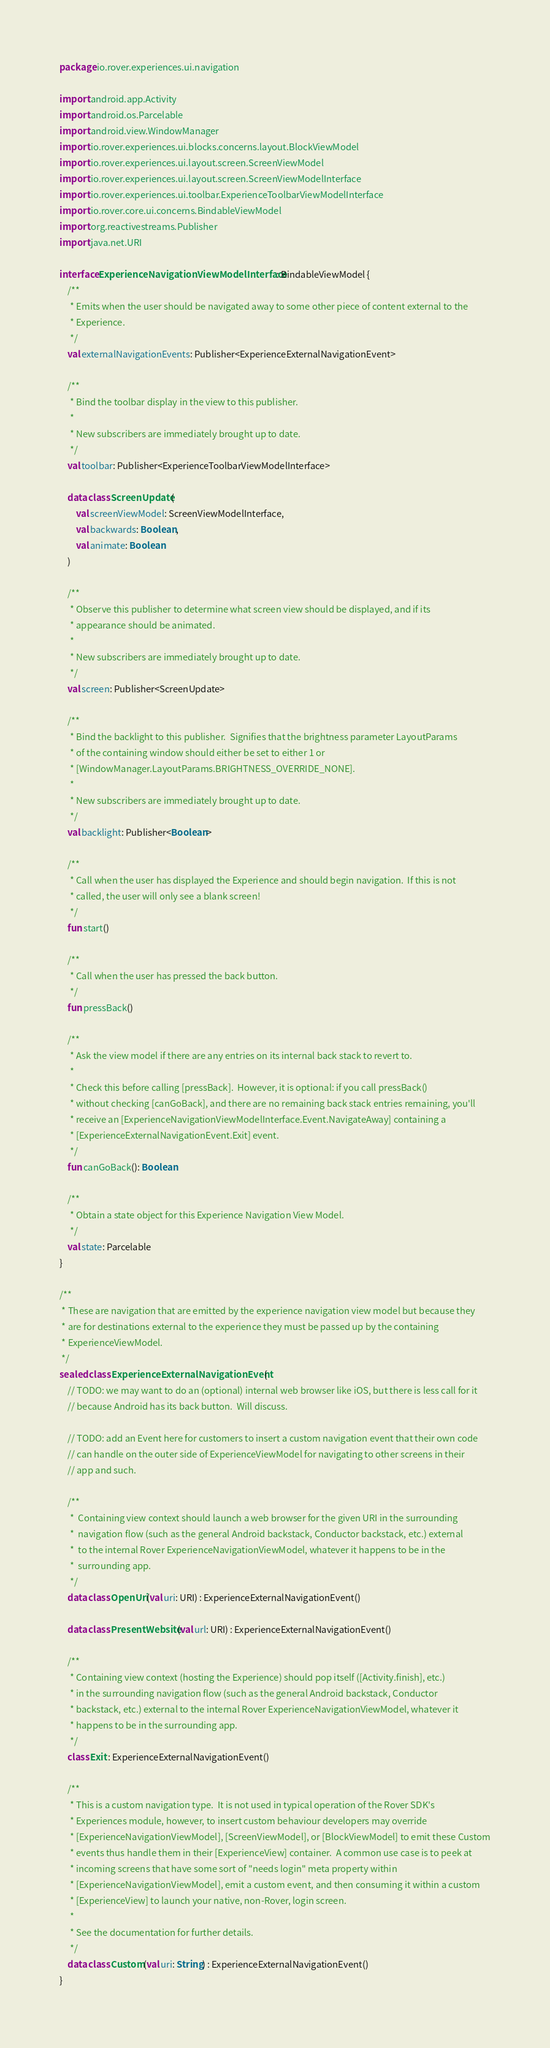Convert code to text. <code><loc_0><loc_0><loc_500><loc_500><_Kotlin_>package io.rover.experiences.ui.navigation

import android.app.Activity
import android.os.Parcelable
import android.view.WindowManager
import io.rover.experiences.ui.blocks.concerns.layout.BlockViewModel
import io.rover.experiences.ui.layout.screen.ScreenViewModel
import io.rover.experiences.ui.layout.screen.ScreenViewModelInterface
import io.rover.experiences.ui.toolbar.ExperienceToolbarViewModelInterface
import io.rover.core.ui.concerns.BindableViewModel
import org.reactivestreams.Publisher
import java.net.URI

interface ExperienceNavigationViewModelInterface : BindableViewModel {
    /**
     * Emits when the user should be navigated away to some other piece of content external to the
     * Experience.
     */
    val externalNavigationEvents: Publisher<ExperienceExternalNavigationEvent>

    /**
     * Bind the toolbar display in the view to this publisher.
     *
     * New subscribers are immediately brought up to date.
     */
    val toolbar: Publisher<ExperienceToolbarViewModelInterface>

    data class ScreenUpdate(
        val screenViewModel: ScreenViewModelInterface,
        val backwards: Boolean,
        val animate: Boolean
    )

    /**
     * Observe this publisher to determine what screen view should be displayed, and if its
     * appearance should be animated.
     *
     * New subscribers are immediately brought up to date.
     */
    val screen: Publisher<ScreenUpdate>

    /**
     * Bind the backlight to this publisher.  Signifies that the brightness parameter LayoutParams
     * of the containing window should either be set to either 1 or
     * [WindowManager.LayoutParams.BRIGHTNESS_OVERRIDE_NONE].
     *
     * New subscribers are immediately brought up to date.
     */
    val backlight: Publisher<Boolean>

    /**
     * Call when the user has displayed the Experience and should begin navigation.  If this is not
     * called, the user will only see a blank screen!
     */
    fun start()

    /**
     * Call when the user has pressed the back button.
     */
    fun pressBack()

    /**
     * Ask the view model if there are any entries on its internal back stack to revert to.
     *
     * Check this before calling [pressBack].  However, it is optional: if you call pressBack()
     * without checking [canGoBack], and there are no remaining back stack entries remaining, you'll
     * receive an [ExperienceNavigationViewModelInterface.Event.NavigateAway] containing a
     * [ExperienceExternalNavigationEvent.Exit] event.
     */
    fun canGoBack(): Boolean

    /**
     * Obtain a state object for this Experience Navigation View Model.
     */
    val state: Parcelable
}

/**
 * These are navigation that are emitted by the experience navigation view model but because they
 * are for destinations external to the experience they must be passed up by the containing
 * ExperienceViewModel.
 */
sealed class ExperienceExternalNavigationEvent {
    // TODO: we may want to do an (optional) internal web browser like iOS, but there is less call for it
    // because Android has its back button.  Will discuss.

    // TODO: add an Event here for customers to insert a custom navigation event that their own code
    // can handle on the outer side of ExperienceViewModel for navigating to other screens in their
    // app and such.

    /**
     *  Containing view context should launch a web browser for the given URI in the surrounding
     *  navigation flow (such as the general Android backstack, Conductor backstack, etc.) external
     *  to the internal Rover ExperienceNavigationViewModel, whatever it happens to be in the
     *  surrounding app.
     */
    data class OpenUri(val uri: URI) : ExperienceExternalNavigationEvent()

    data class PresentWebsite(val url: URI) : ExperienceExternalNavigationEvent()

    /**
     * Containing view context (hosting the Experience) should pop itself ([Activity.finish], etc.)
     * in the surrounding navigation flow (such as the general Android backstack, Conductor
     * backstack, etc.) external to the internal Rover ExperienceNavigationViewModel, whatever it
     * happens to be in the surrounding app.
     */
    class Exit : ExperienceExternalNavigationEvent()

    /**
     * This is a custom navigation type.  It is not used in typical operation of the Rover SDK's
     * Experiences module, however, to insert custom behaviour developers may override
     * [ExperienceNavigationViewModel], [ScreenViewModel], or [BlockViewModel] to emit these Custom
     * events thus handle them in their [ExperienceView] container.  A common use case is to peek at
     * incoming screens that have some sort of "needs login" meta property within
     * [ExperienceNavigationViewModel], emit a custom event, and then consuming it within a custom
     * [ExperienceView] to launch your native, non-Rover, login screen.
     *
     * See the documentation for further details.
     */
    data class Custom(val uri: String) : ExperienceExternalNavigationEvent()
}
</code> 